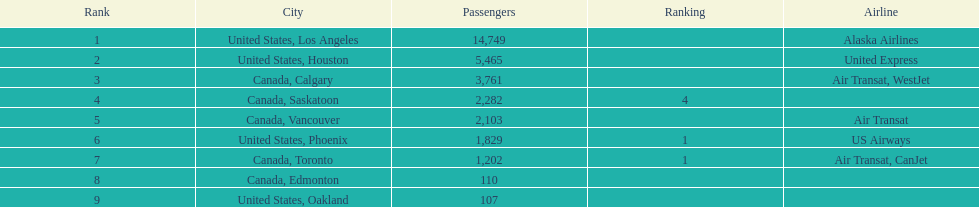The difference in passengers between los angeles and toronto 13,547. 